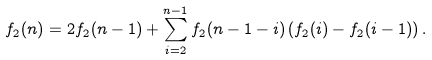Convert formula to latex. <formula><loc_0><loc_0><loc_500><loc_500>f _ { 2 } ( n ) = 2 f _ { 2 } ( n - 1 ) + \sum _ { i = 2 } ^ { n - 1 } f _ { 2 } ( n - 1 - i ) \left ( f _ { 2 } ( i ) - f _ { 2 } ( i - 1 ) \right ) .</formula> 